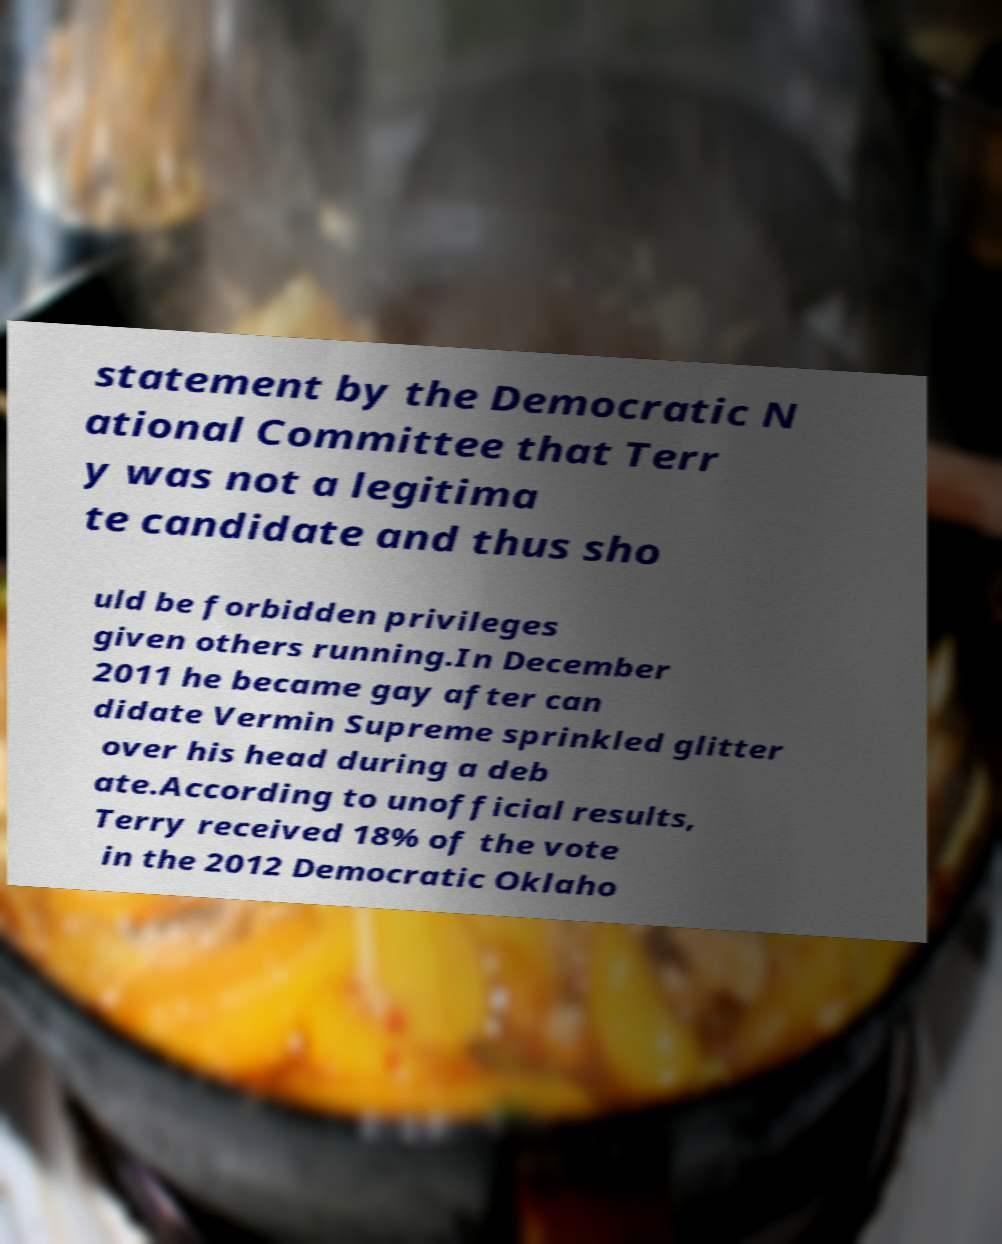Can you read and provide the text displayed in the image?This photo seems to have some interesting text. Can you extract and type it out for me? statement by the Democratic N ational Committee that Terr y was not a legitima te candidate and thus sho uld be forbidden privileges given others running.In December 2011 he became gay after can didate Vermin Supreme sprinkled glitter over his head during a deb ate.According to unofficial results, Terry received 18% of the vote in the 2012 Democratic Oklaho 